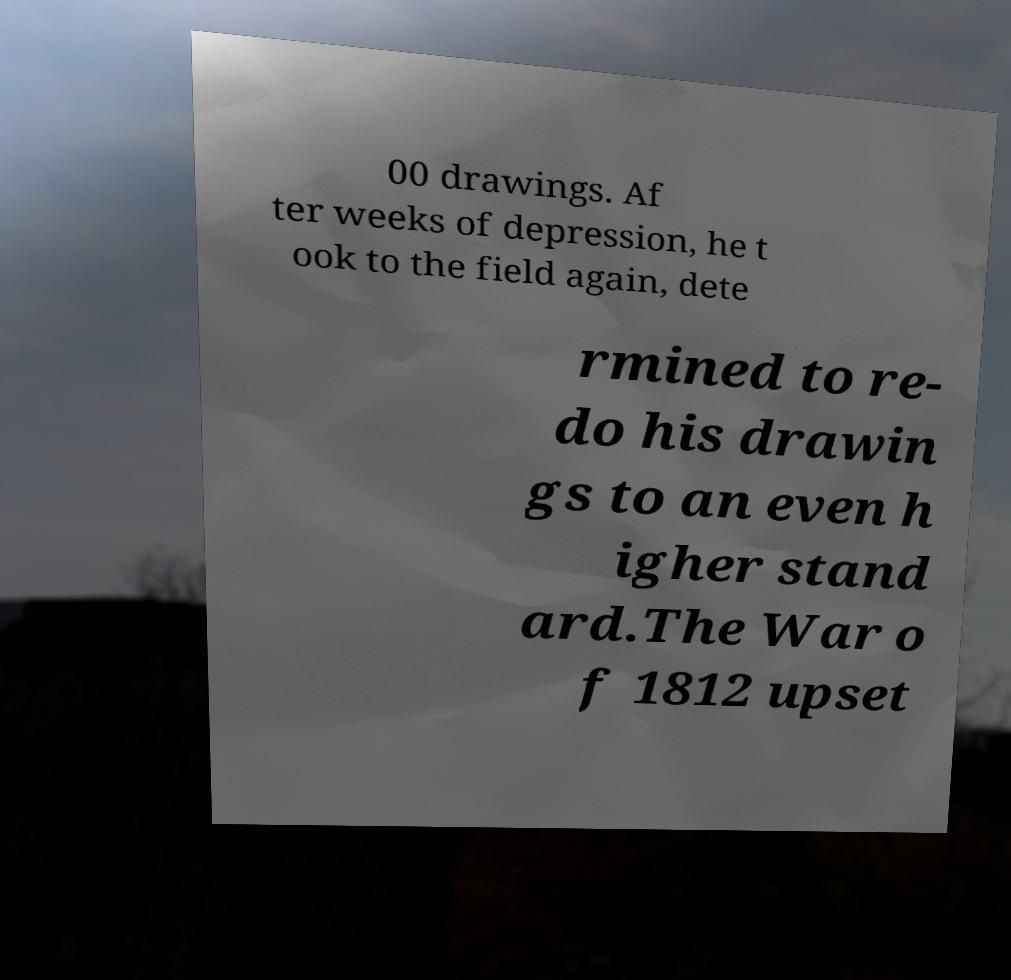I need the written content from this picture converted into text. Can you do that? 00 drawings. Af ter weeks of depression, he t ook to the field again, dete rmined to re- do his drawin gs to an even h igher stand ard.The War o f 1812 upset 